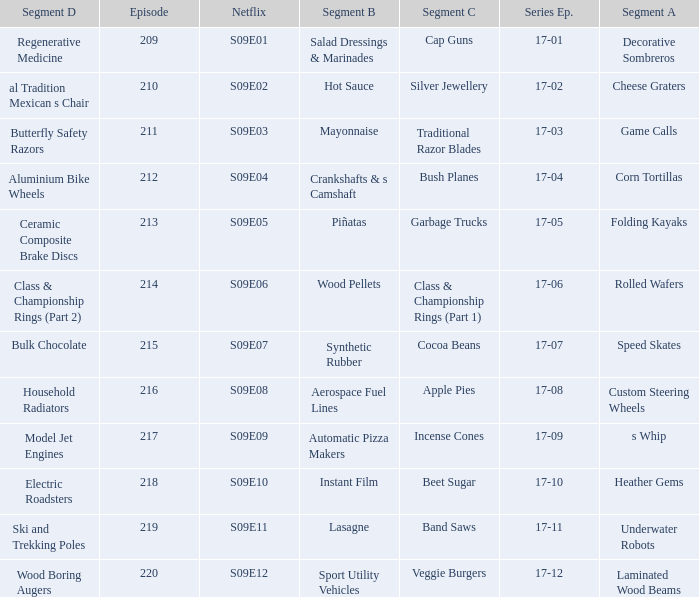For the shows featuring beet sugar, what was on before that Instant Film. 